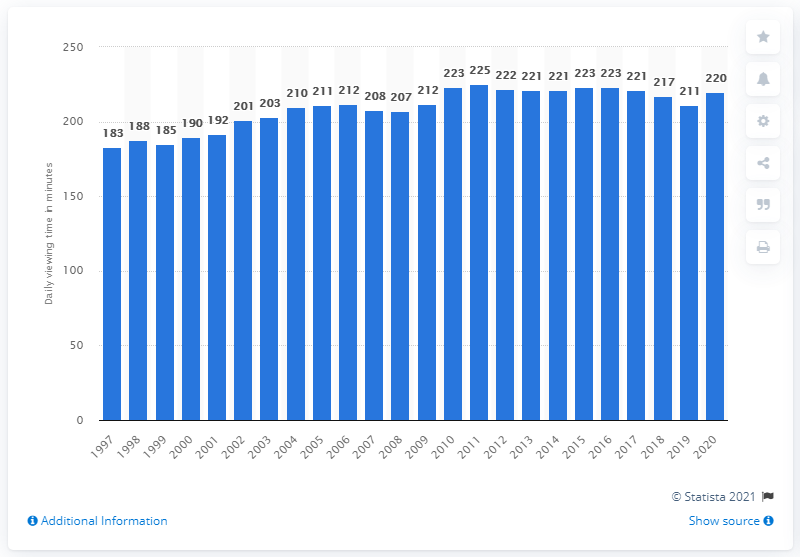Point out several critical features in this image. The average German spent approximately 220 minutes watching television per day in 2020. 